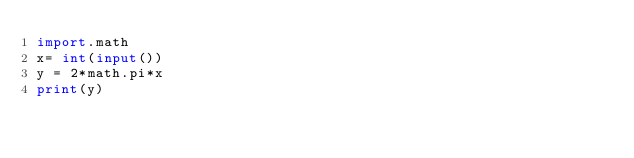Convert code to text. <code><loc_0><loc_0><loc_500><loc_500><_Python_>import.math
x= int(input())
y = 2*math.pi*x
print(y)</code> 